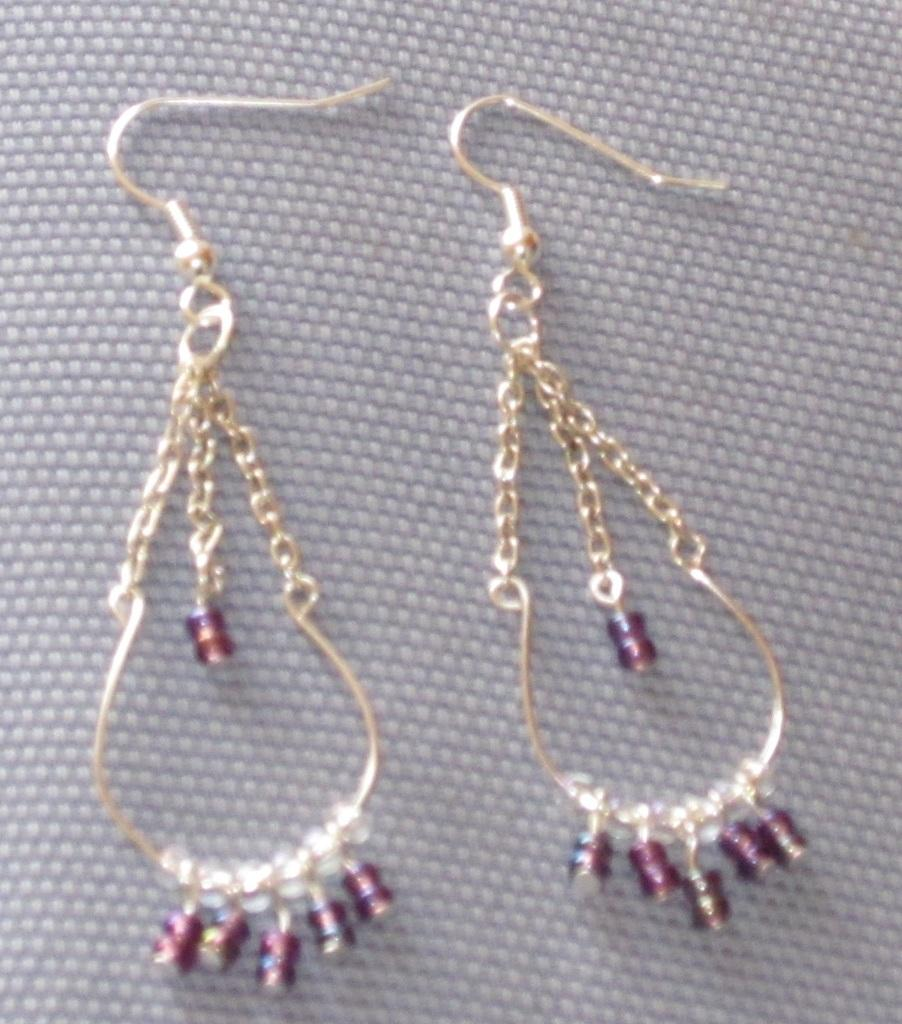What type of accessory is featured in the image? There are two design earrings in the image. Can you describe the design of the earrings? Unfortunately, the design of the earrings cannot be determined from the provided facts. How many ladybugs are crawling on the earrings in the image? There are no ladybugs present in the image; it only features two design earrings. 